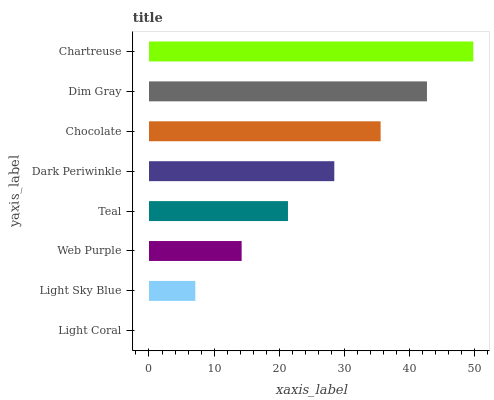Is Light Coral the minimum?
Answer yes or no. Yes. Is Chartreuse the maximum?
Answer yes or no. Yes. Is Light Sky Blue the minimum?
Answer yes or no. No. Is Light Sky Blue the maximum?
Answer yes or no. No. Is Light Sky Blue greater than Light Coral?
Answer yes or no. Yes. Is Light Coral less than Light Sky Blue?
Answer yes or no. Yes. Is Light Coral greater than Light Sky Blue?
Answer yes or no. No. Is Light Sky Blue less than Light Coral?
Answer yes or no. No. Is Dark Periwinkle the high median?
Answer yes or no. Yes. Is Teal the low median?
Answer yes or no. Yes. Is Chocolate the high median?
Answer yes or no. No. Is Light Sky Blue the low median?
Answer yes or no. No. 